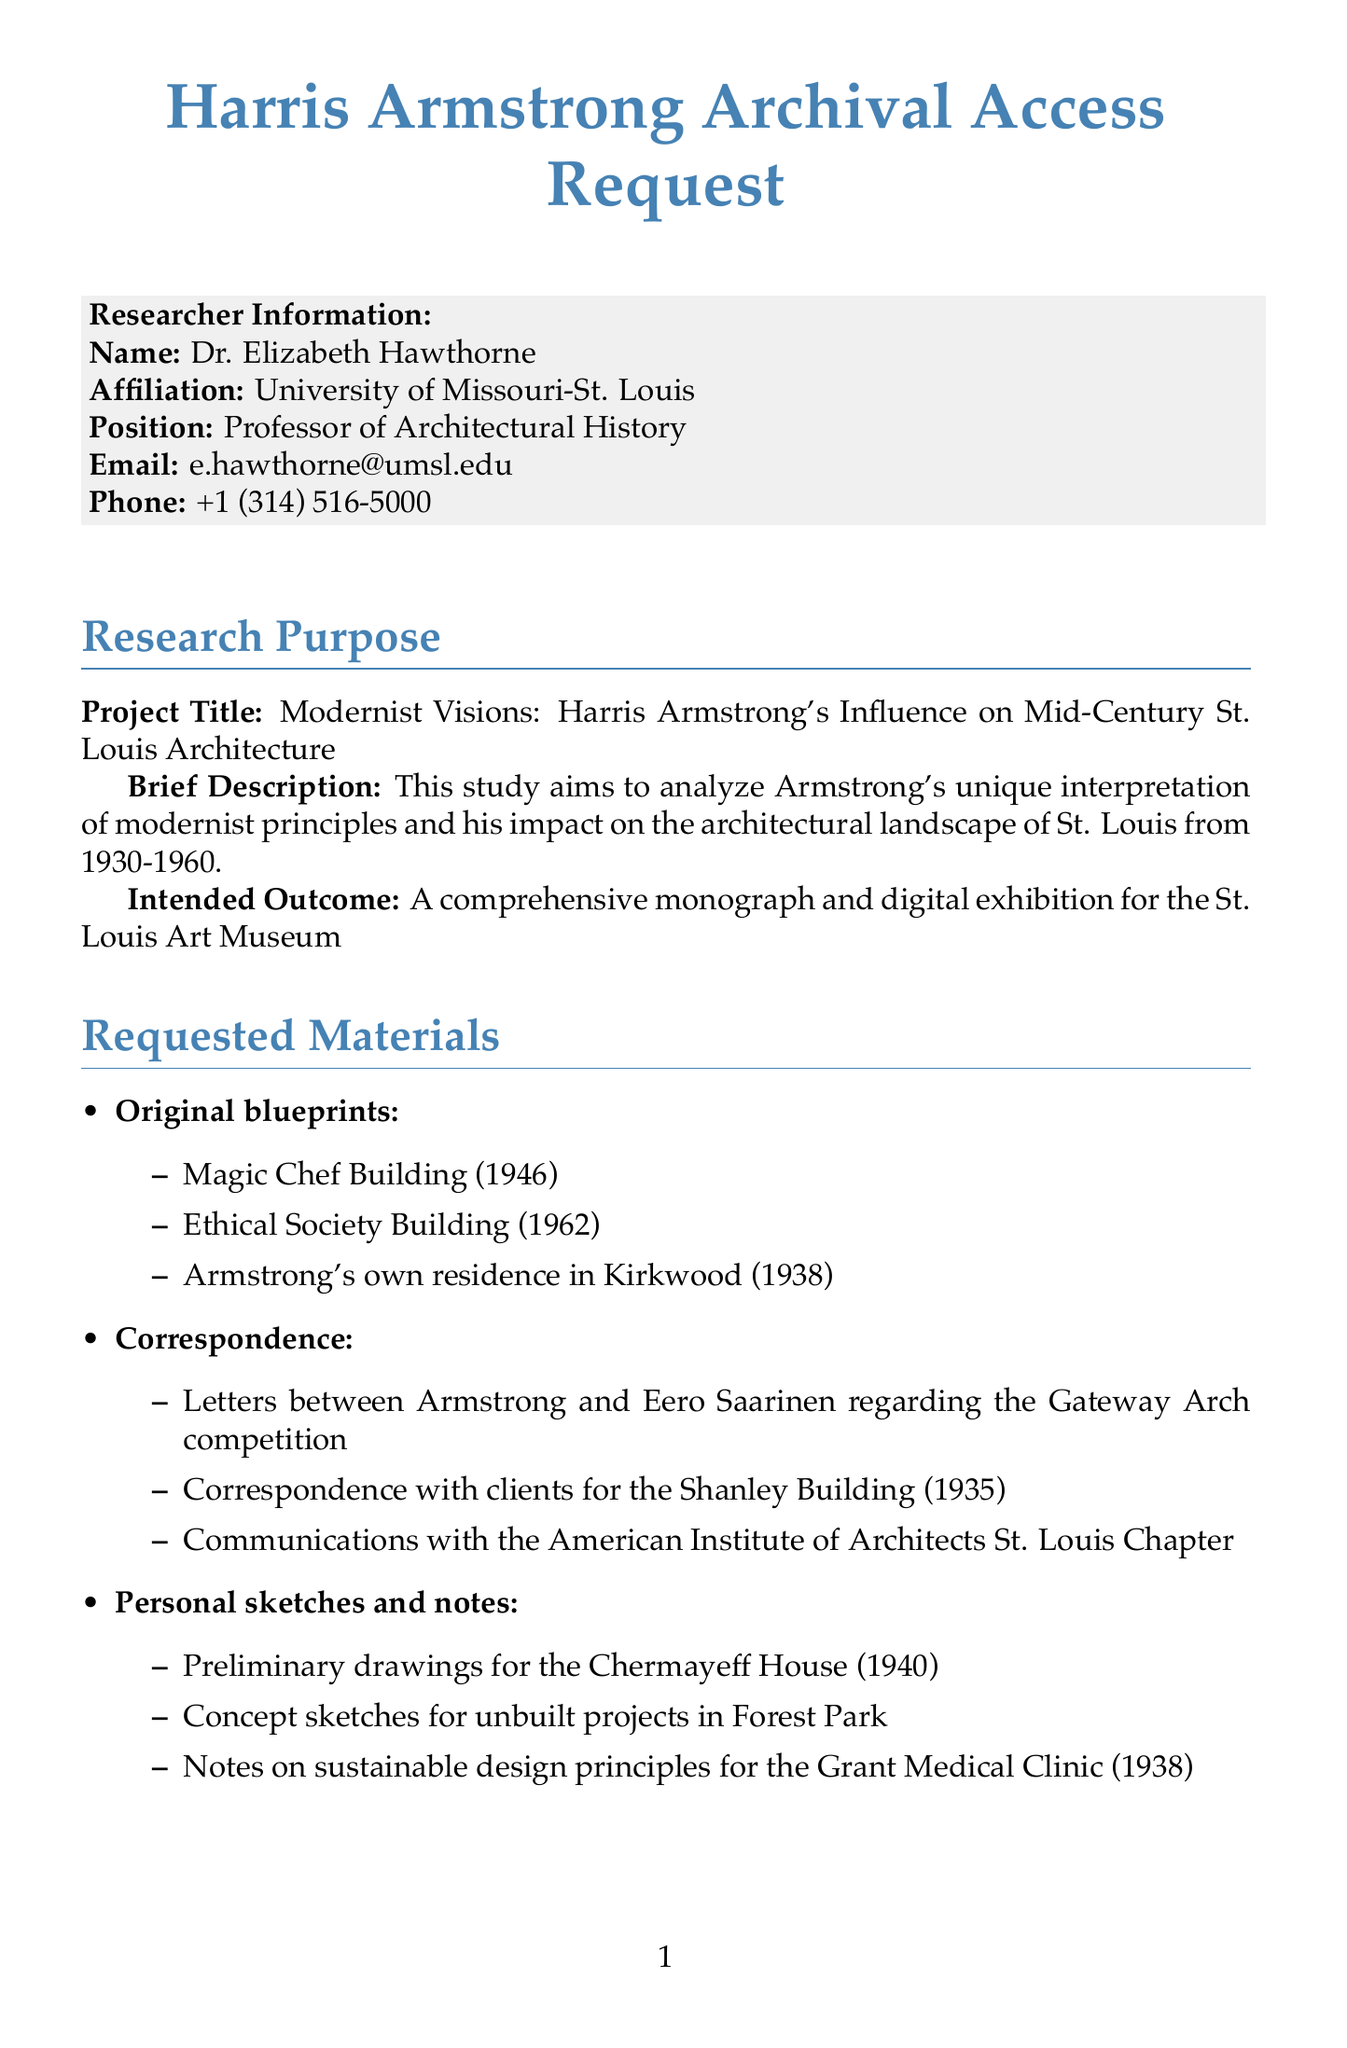what is the research project title? The project title is specified in the research purpose section of the document.
Answer: Modernist Visions: Harris Armstrong's Influence on Mid-Century St. Louis Architecture who is the researcher? The document includes the researcher's name in the researcher information section.
Answer: Dr. Elizabeth Hawthorne what is the access period for the archival materials? The access period indicates when materials can be accessed according to the archive details section.
Answer: September 15, 2023 - December 15, 2023 name one of the requested materials. The requested materials section lists specific documents intended for access by the researcher.
Answer: Original blueprints how many specific items are listed under correspondence? This question requires counting the specific items listed in the correspondence section of the requested materials.
Answer: 3 what is the intended outcome of the research? The intended outcome is mentioned in the research purpose section.
Answer: A comprehensive monograph and digital exhibition for the St. Louis Art Museum what special requirement involves equipment? This question focuses on the special requirements related to equipment as noted in the document.
Answer: Access to high-resolution scanning equipment for blueprint digitization how will the researcher handle the materials? The document specifies handling instructions that the researcher agrees to follow.
Answer: Using provided gloves and following the archive's preservation guidelines 